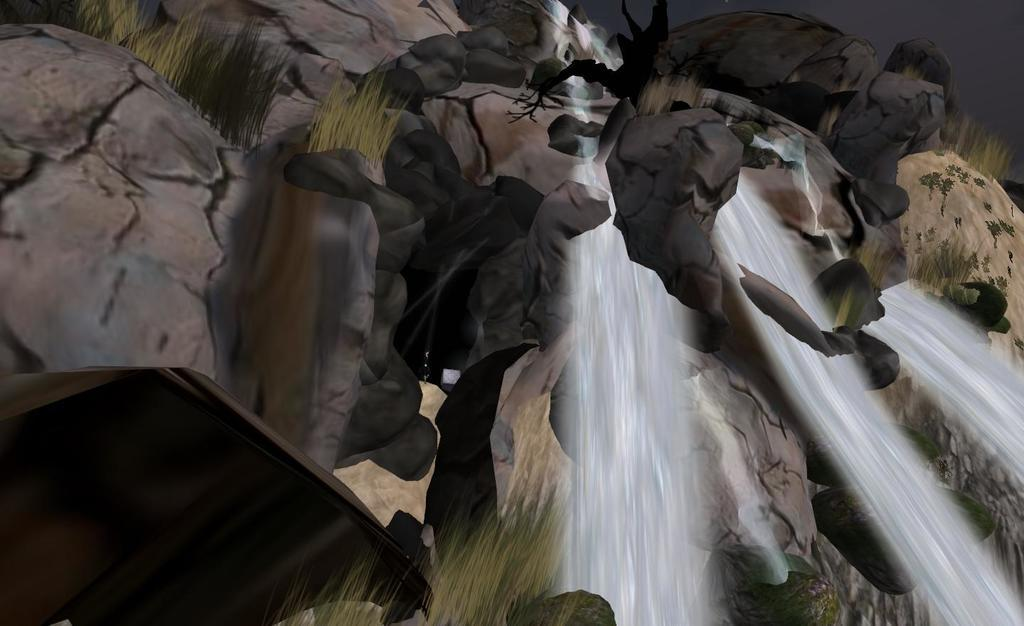What type of image is being described? The image appears to be animated. What natural feature can be seen in the image? There is a waterfall in the image. How is the waterfall depicted in the image? Water is flowing in the waterfall. What type of landscape is visible in the image? There are hills in the image. What type of vegetation is present in the image? Grass is visible in the image. What is the school's address in the image? There is no school present in the image, so it is not possible to determine its address. 